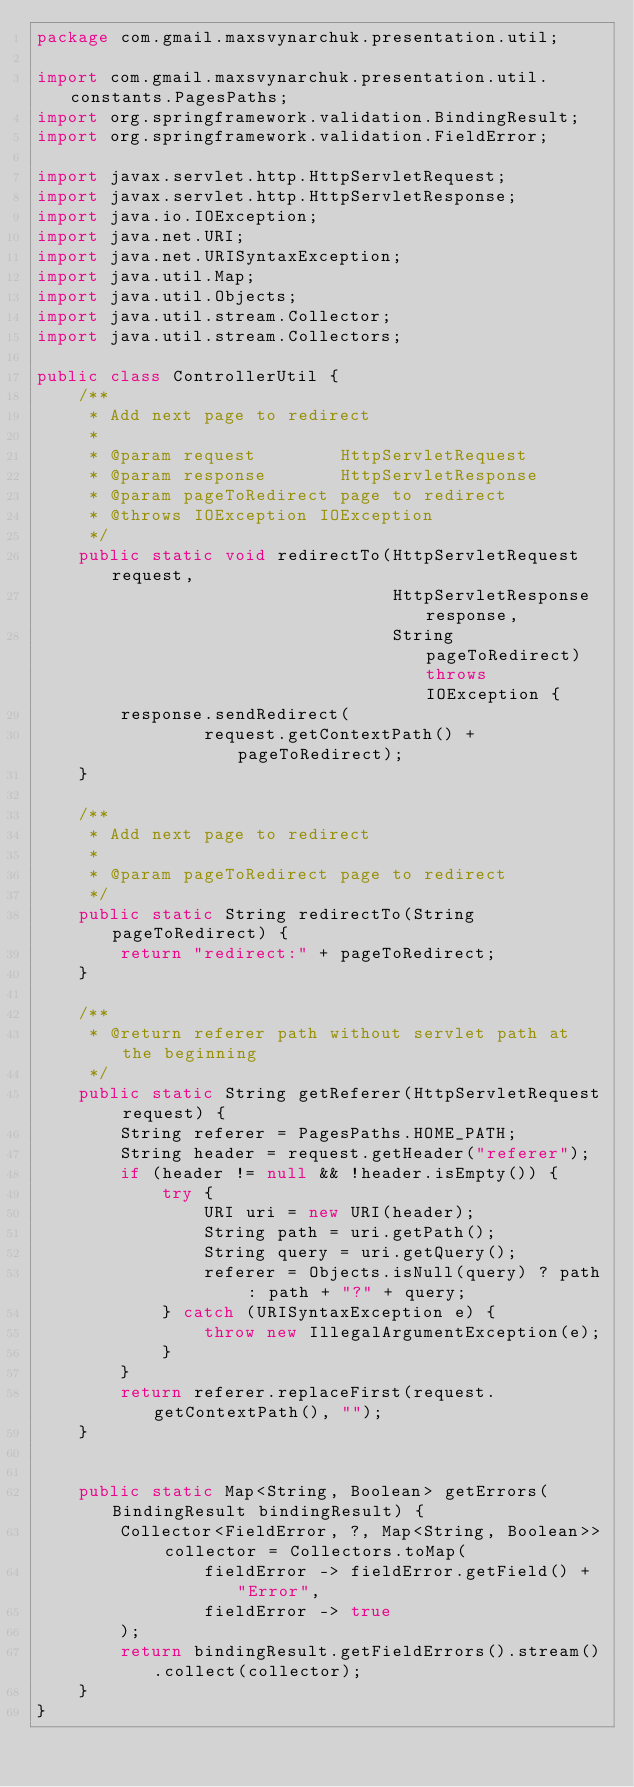<code> <loc_0><loc_0><loc_500><loc_500><_Java_>package com.gmail.maxsvynarchuk.presentation.util;

import com.gmail.maxsvynarchuk.presentation.util.constants.PagesPaths;
import org.springframework.validation.BindingResult;
import org.springframework.validation.FieldError;

import javax.servlet.http.HttpServletRequest;
import javax.servlet.http.HttpServletResponse;
import java.io.IOException;
import java.net.URI;
import java.net.URISyntaxException;
import java.util.Map;
import java.util.Objects;
import java.util.stream.Collector;
import java.util.stream.Collectors;

public class ControllerUtil {
    /**
     * Add next page to redirect
     *
     * @param request        HttpServletRequest
     * @param response       HttpServletResponse
     * @param pageToRedirect page to redirect
     * @throws IOException IOException
     */
    public static void redirectTo(HttpServletRequest request,
                                  HttpServletResponse response,
                                  String pageToRedirect) throws IOException {
        response.sendRedirect(
                request.getContextPath() + pageToRedirect);
    }

    /**
     * Add next page to redirect
     *
     * @param pageToRedirect page to redirect
     */
    public static String redirectTo(String pageToRedirect) {
        return "redirect:" + pageToRedirect;
    }

    /**
     * @return referer path without servlet path at the beginning
     */
    public static String getReferer(HttpServletRequest request) {
        String referer = PagesPaths.HOME_PATH;
        String header = request.getHeader("referer");
        if (header != null && !header.isEmpty()) {
            try {
                URI uri = new URI(header);
                String path = uri.getPath();
                String query = uri.getQuery();
                referer = Objects.isNull(query) ? path : path + "?" + query;
            } catch (URISyntaxException e) {
                throw new IllegalArgumentException(e);
            }
        }
        return referer.replaceFirst(request.getContextPath(), "");
    }


    public static Map<String, Boolean> getErrors(BindingResult bindingResult) {
        Collector<FieldError, ?, Map<String, Boolean>> collector = Collectors.toMap(
                fieldError -> fieldError.getField() + "Error",
                fieldError -> true
        );
        return bindingResult.getFieldErrors().stream().collect(collector);
    }
}
</code> 